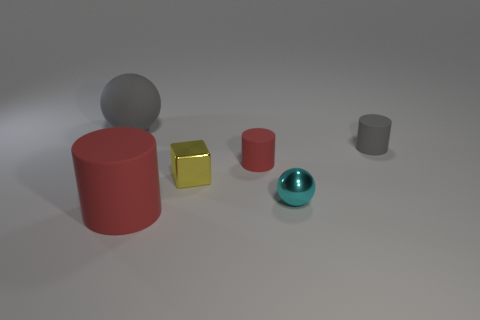The rubber object in front of the red cylinder that is behind the big rubber object that is right of the gray ball is what shape?
Ensure brevity in your answer.  Cylinder. Are there any yellow blocks of the same size as the cyan metal sphere?
Ensure brevity in your answer.  Yes. The cyan metallic object is what size?
Your answer should be very brief. Small. What number of gray rubber objects have the same size as the cyan metal thing?
Provide a short and direct response. 1. Is the number of small yellow objects behind the yellow shiny object less than the number of red cylinders left of the large gray thing?
Provide a short and direct response. No. What size is the ball that is on the left side of the red object to the right of the red matte object that is in front of the yellow block?
Make the answer very short. Large. There is a object that is on the left side of the yellow cube and behind the tiny yellow cube; what size is it?
Give a very brief answer. Large. The gray thing in front of the big matte object behind the small gray matte thing is what shape?
Your response must be concise. Cylinder. Are there any other things of the same color as the metallic sphere?
Offer a very short reply. No. There is a tiny metallic thing right of the small metal cube; what is its shape?
Offer a terse response. Sphere. 